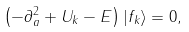Convert formula to latex. <formula><loc_0><loc_0><loc_500><loc_500>\left ( - \partial _ { a } ^ { 2 } + U _ { k } - E \right ) | f _ { k } \rangle = 0 ,</formula> 